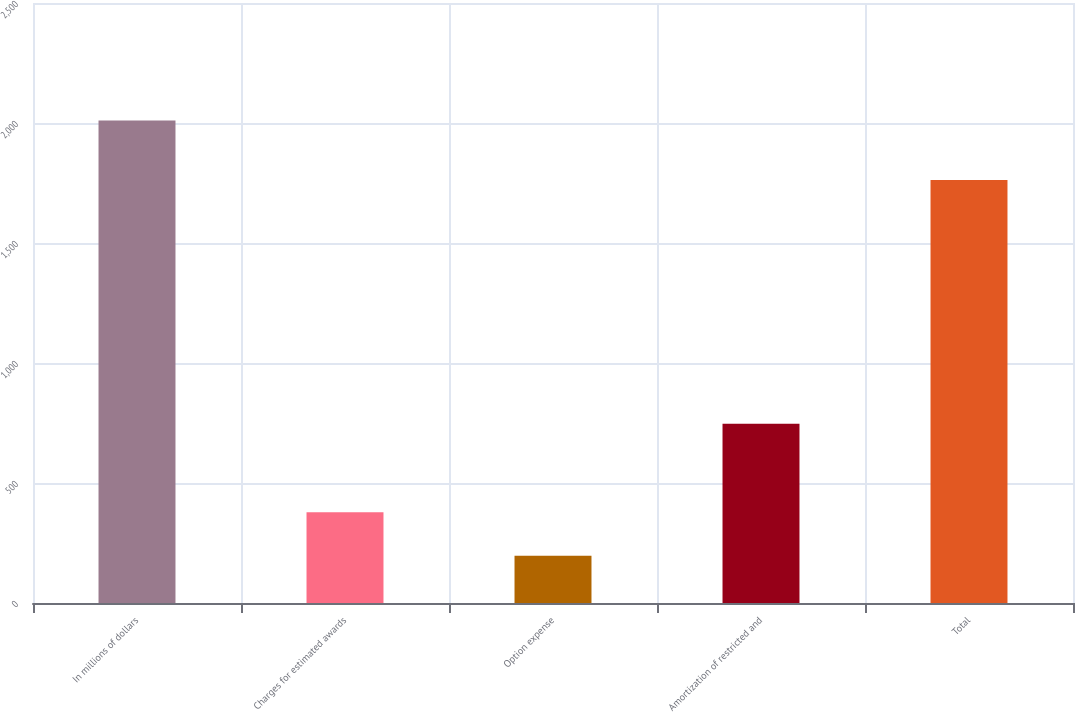Convert chart. <chart><loc_0><loc_0><loc_500><loc_500><bar_chart><fcel>In millions of dollars<fcel>Charges for estimated awards<fcel>Option expense<fcel>Amortization of restricted and<fcel>Total<nl><fcel>2010<fcel>378.3<fcel>197<fcel>747<fcel>1763<nl></chart> 